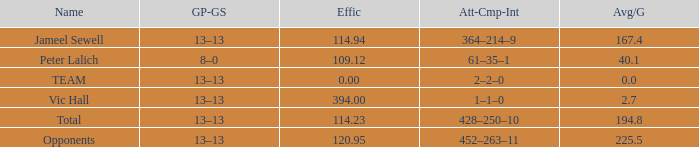Avg/G that has a GP-GS of 13–13, and a Effic smaller than 114.23 has what total of numbers? 1.0. 